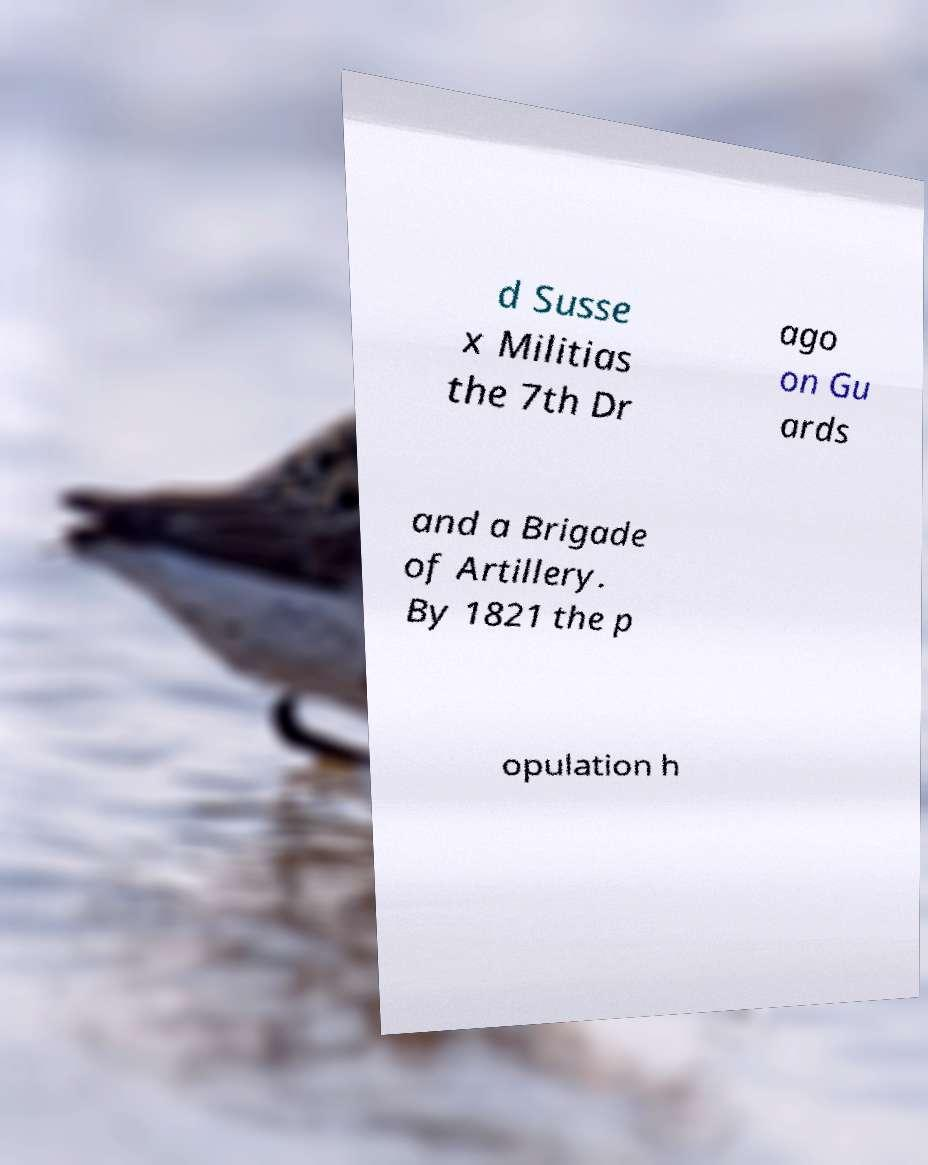Could you extract and type out the text from this image? d Susse x Militias the 7th Dr ago on Gu ards and a Brigade of Artillery. By 1821 the p opulation h 